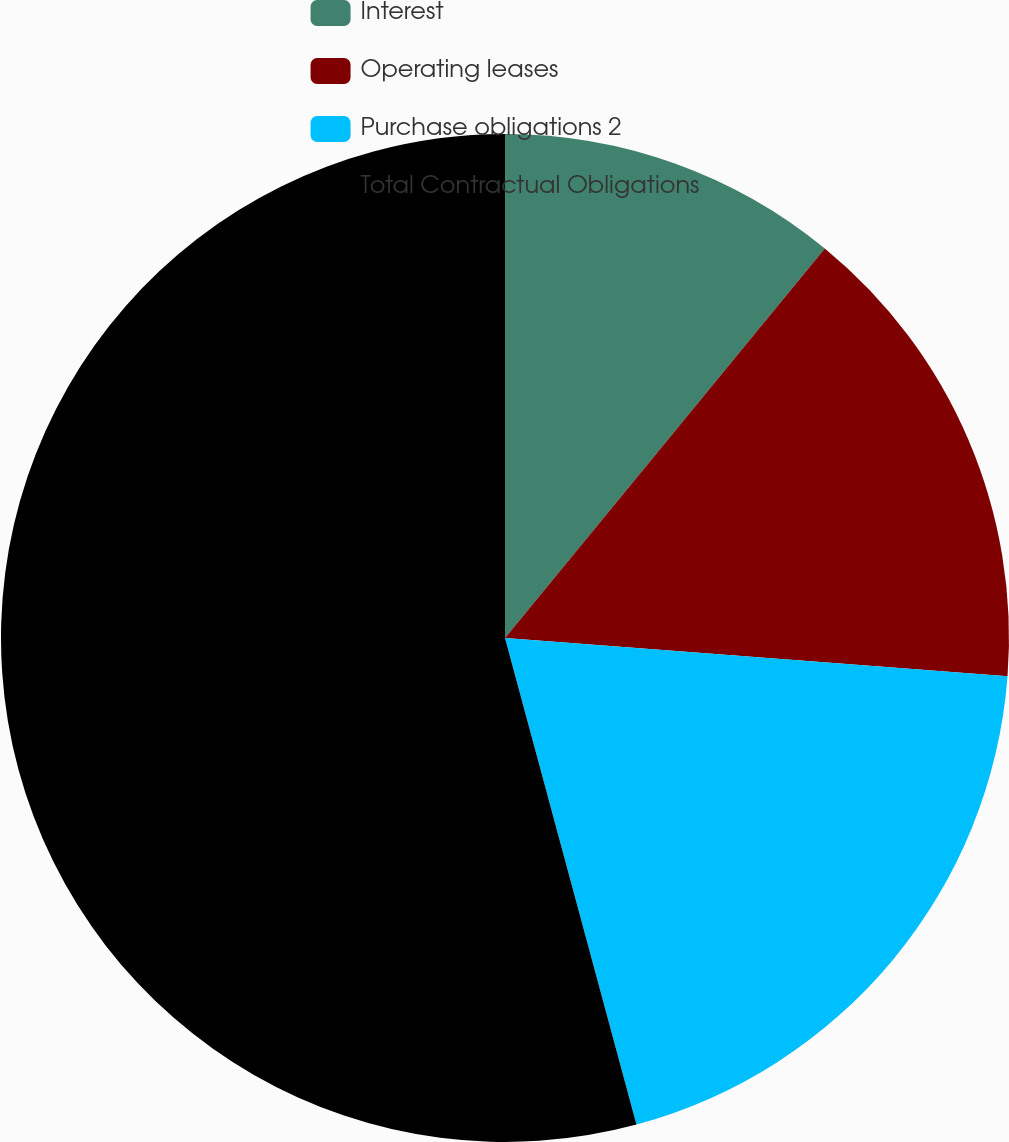<chart> <loc_0><loc_0><loc_500><loc_500><pie_chart><fcel>Interest<fcel>Operating leases<fcel>Purchase obligations 2<fcel>Total Contractual Obligations<nl><fcel>10.94%<fcel>15.27%<fcel>19.59%<fcel>54.2%<nl></chart> 